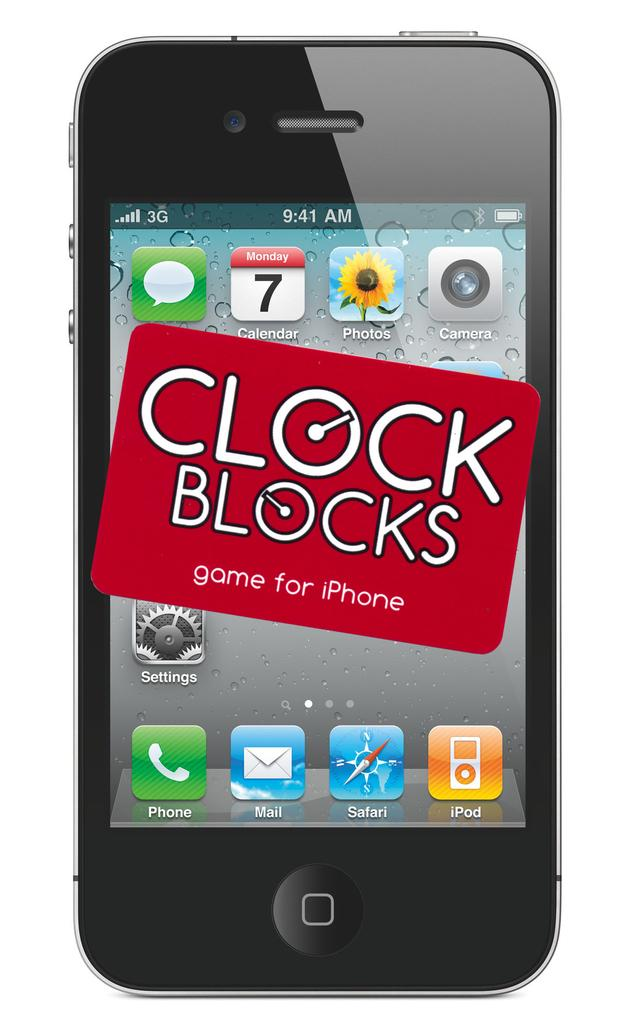<image>
Give a short and clear explanation of the subsequent image. The iphone has an advertisement for a game called clock blocks. 